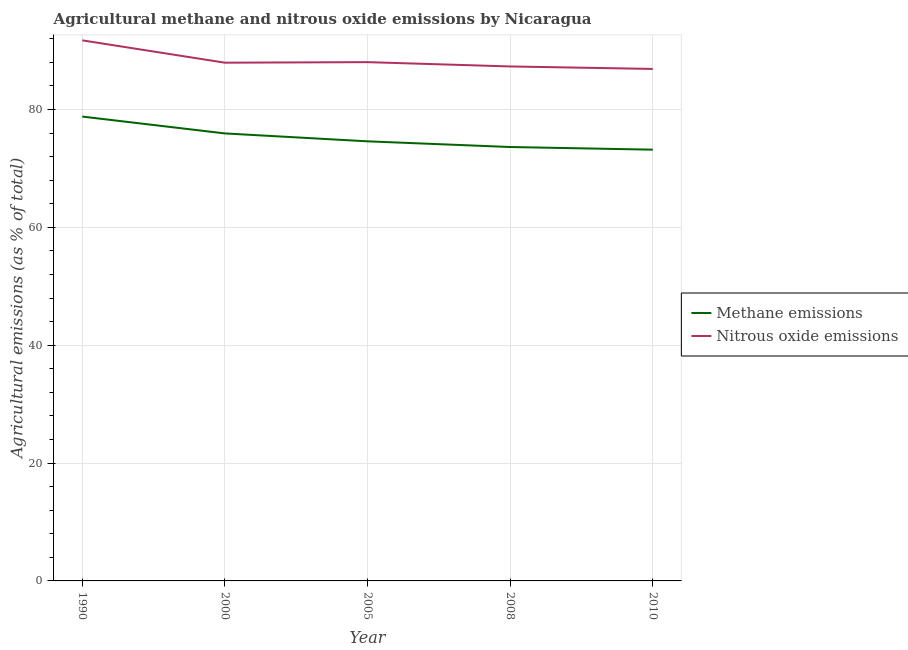What is the amount of methane emissions in 2010?
Offer a terse response. 73.19. Across all years, what is the maximum amount of methane emissions?
Your response must be concise. 78.81. Across all years, what is the minimum amount of nitrous oxide emissions?
Provide a short and direct response. 86.89. In which year was the amount of nitrous oxide emissions maximum?
Keep it short and to the point. 1990. In which year was the amount of nitrous oxide emissions minimum?
Ensure brevity in your answer.  2010. What is the total amount of methane emissions in the graph?
Make the answer very short. 376.2. What is the difference between the amount of methane emissions in 1990 and that in 2005?
Provide a succinct answer. 4.2. What is the difference between the amount of methane emissions in 2008 and the amount of nitrous oxide emissions in 1990?
Give a very brief answer. -18.1. What is the average amount of methane emissions per year?
Your answer should be compact. 75.24. In the year 2000, what is the difference between the amount of methane emissions and amount of nitrous oxide emissions?
Your response must be concise. -12.01. What is the ratio of the amount of nitrous oxide emissions in 2000 to that in 2008?
Offer a very short reply. 1.01. Is the difference between the amount of methane emissions in 2005 and 2010 greater than the difference between the amount of nitrous oxide emissions in 2005 and 2010?
Give a very brief answer. Yes. What is the difference between the highest and the second highest amount of methane emissions?
Offer a very short reply. 2.86. What is the difference between the highest and the lowest amount of nitrous oxide emissions?
Give a very brief answer. 4.85. In how many years, is the amount of nitrous oxide emissions greater than the average amount of nitrous oxide emissions taken over all years?
Give a very brief answer. 1. Is the amount of nitrous oxide emissions strictly greater than the amount of methane emissions over the years?
Keep it short and to the point. Yes. Is the amount of nitrous oxide emissions strictly less than the amount of methane emissions over the years?
Offer a very short reply. No. How many lines are there?
Offer a very short reply. 2. Does the graph contain any zero values?
Your answer should be very brief. No. How many legend labels are there?
Provide a succinct answer. 2. What is the title of the graph?
Provide a short and direct response. Agricultural methane and nitrous oxide emissions by Nicaragua. Does "UN agencies" appear as one of the legend labels in the graph?
Your answer should be compact. No. What is the label or title of the X-axis?
Give a very brief answer. Year. What is the label or title of the Y-axis?
Your answer should be very brief. Agricultural emissions (as % of total). What is the Agricultural emissions (as % of total) in Methane emissions in 1990?
Provide a succinct answer. 78.81. What is the Agricultural emissions (as % of total) in Nitrous oxide emissions in 1990?
Ensure brevity in your answer.  91.75. What is the Agricultural emissions (as % of total) in Methane emissions in 2000?
Your response must be concise. 75.95. What is the Agricultural emissions (as % of total) of Nitrous oxide emissions in 2000?
Keep it short and to the point. 87.95. What is the Agricultural emissions (as % of total) of Methane emissions in 2005?
Offer a terse response. 74.61. What is the Agricultural emissions (as % of total) of Nitrous oxide emissions in 2005?
Provide a succinct answer. 88.05. What is the Agricultural emissions (as % of total) of Methane emissions in 2008?
Offer a terse response. 73.64. What is the Agricultural emissions (as % of total) in Nitrous oxide emissions in 2008?
Keep it short and to the point. 87.32. What is the Agricultural emissions (as % of total) of Methane emissions in 2010?
Provide a short and direct response. 73.19. What is the Agricultural emissions (as % of total) in Nitrous oxide emissions in 2010?
Provide a succinct answer. 86.89. Across all years, what is the maximum Agricultural emissions (as % of total) in Methane emissions?
Keep it short and to the point. 78.81. Across all years, what is the maximum Agricultural emissions (as % of total) of Nitrous oxide emissions?
Keep it short and to the point. 91.75. Across all years, what is the minimum Agricultural emissions (as % of total) of Methane emissions?
Your answer should be very brief. 73.19. Across all years, what is the minimum Agricultural emissions (as % of total) of Nitrous oxide emissions?
Ensure brevity in your answer.  86.89. What is the total Agricultural emissions (as % of total) of Methane emissions in the graph?
Provide a short and direct response. 376.2. What is the total Agricultural emissions (as % of total) in Nitrous oxide emissions in the graph?
Offer a terse response. 441.96. What is the difference between the Agricultural emissions (as % of total) in Methane emissions in 1990 and that in 2000?
Your response must be concise. 2.86. What is the difference between the Agricultural emissions (as % of total) of Nitrous oxide emissions in 1990 and that in 2000?
Keep it short and to the point. 3.79. What is the difference between the Agricultural emissions (as % of total) in Methane emissions in 1990 and that in 2005?
Make the answer very short. 4.2. What is the difference between the Agricultural emissions (as % of total) of Nitrous oxide emissions in 1990 and that in 2005?
Keep it short and to the point. 3.7. What is the difference between the Agricultural emissions (as % of total) in Methane emissions in 1990 and that in 2008?
Provide a succinct answer. 5.17. What is the difference between the Agricultural emissions (as % of total) in Nitrous oxide emissions in 1990 and that in 2008?
Give a very brief answer. 4.43. What is the difference between the Agricultural emissions (as % of total) of Methane emissions in 1990 and that in 2010?
Provide a succinct answer. 5.62. What is the difference between the Agricultural emissions (as % of total) of Nitrous oxide emissions in 1990 and that in 2010?
Provide a short and direct response. 4.85. What is the difference between the Agricultural emissions (as % of total) in Methane emissions in 2000 and that in 2005?
Your response must be concise. 1.34. What is the difference between the Agricultural emissions (as % of total) of Nitrous oxide emissions in 2000 and that in 2005?
Offer a very short reply. -0.09. What is the difference between the Agricultural emissions (as % of total) of Methane emissions in 2000 and that in 2008?
Your answer should be very brief. 2.31. What is the difference between the Agricultural emissions (as % of total) in Nitrous oxide emissions in 2000 and that in 2008?
Your response must be concise. 0.64. What is the difference between the Agricultural emissions (as % of total) of Methane emissions in 2000 and that in 2010?
Give a very brief answer. 2.76. What is the difference between the Agricultural emissions (as % of total) of Nitrous oxide emissions in 2000 and that in 2010?
Your response must be concise. 1.06. What is the difference between the Agricultural emissions (as % of total) of Methane emissions in 2005 and that in 2008?
Keep it short and to the point. 0.96. What is the difference between the Agricultural emissions (as % of total) of Nitrous oxide emissions in 2005 and that in 2008?
Ensure brevity in your answer.  0.73. What is the difference between the Agricultural emissions (as % of total) in Methane emissions in 2005 and that in 2010?
Offer a very short reply. 1.42. What is the difference between the Agricultural emissions (as % of total) of Nitrous oxide emissions in 2005 and that in 2010?
Keep it short and to the point. 1.15. What is the difference between the Agricultural emissions (as % of total) of Methane emissions in 2008 and that in 2010?
Your response must be concise. 0.45. What is the difference between the Agricultural emissions (as % of total) of Nitrous oxide emissions in 2008 and that in 2010?
Provide a short and direct response. 0.42. What is the difference between the Agricultural emissions (as % of total) of Methane emissions in 1990 and the Agricultural emissions (as % of total) of Nitrous oxide emissions in 2000?
Provide a short and direct response. -9.14. What is the difference between the Agricultural emissions (as % of total) in Methane emissions in 1990 and the Agricultural emissions (as % of total) in Nitrous oxide emissions in 2005?
Your answer should be very brief. -9.24. What is the difference between the Agricultural emissions (as % of total) of Methane emissions in 1990 and the Agricultural emissions (as % of total) of Nitrous oxide emissions in 2008?
Your response must be concise. -8.51. What is the difference between the Agricultural emissions (as % of total) in Methane emissions in 1990 and the Agricultural emissions (as % of total) in Nitrous oxide emissions in 2010?
Your answer should be very brief. -8.08. What is the difference between the Agricultural emissions (as % of total) in Methane emissions in 2000 and the Agricultural emissions (as % of total) in Nitrous oxide emissions in 2005?
Offer a terse response. -12.1. What is the difference between the Agricultural emissions (as % of total) of Methane emissions in 2000 and the Agricultural emissions (as % of total) of Nitrous oxide emissions in 2008?
Your response must be concise. -11.37. What is the difference between the Agricultural emissions (as % of total) of Methane emissions in 2000 and the Agricultural emissions (as % of total) of Nitrous oxide emissions in 2010?
Make the answer very short. -10.94. What is the difference between the Agricultural emissions (as % of total) of Methane emissions in 2005 and the Agricultural emissions (as % of total) of Nitrous oxide emissions in 2008?
Make the answer very short. -12.71. What is the difference between the Agricultural emissions (as % of total) of Methane emissions in 2005 and the Agricultural emissions (as % of total) of Nitrous oxide emissions in 2010?
Make the answer very short. -12.29. What is the difference between the Agricultural emissions (as % of total) of Methane emissions in 2008 and the Agricultural emissions (as % of total) of Nitrous oxide emissions in 2010?
Your response must be concise. -13.25. What is the average Agricultural emissions (as % of total) in Methane emissions per year?
Keep it short and to the point. 75.24. What is the average Agricultural emissions (as % of total) in Nitrous oxide emissions per year?
Ensure brevity in your answer.  88.39. In the year 1990, what is the difference between the Agricultural emissions (as % of total) in Methane emissions and Agricultural emissions (as % of total) in Nitrous oxide emissions?
Give a very brief answer. -12.94. In the year 2000, what is the difference between the Agricultural emissions (as % of total) of Methane emissions and Agricultural emissions (as % of total) of Nitrous oxide emissions?
Give a very brief answer. -12.01. In the year 2005, what is the difference between the Agricultural emissions (as % of total) in Methane emissions and Agricultural emissions (as % of total) in Nitrous oxide emissions?
Provide a short and direct response. -13.44. In the year 2008, what is the difference between the Agricultural emissions (as % of total) in Methane emissions and Agricultural emissions (as % of total) in Nitrous oxide emissions?
Provide a succinct answer. -13.67. In the year 2010, what is the difference between the Agricultural emissions (as % of total) in Methane emissions and Agricultural emissions (as % of total) in Nitrous oxide emissions?
Make the answer very short. -13.7. What is the ratio of the Agricultural emissions (as % of total) of Methane emissions in 1990 to that in 2000?
Make the answer very short. 1.04. What is the ratio of the Agricultural emissions (as % of total) of Nitrous oxide emissions in 1990 to that in 2000?
Keep it short and to the point. 1.04. What is the ratio of the Agricultural emissions (as % of total) of Methane emissions in 1990 to that in 2005?
Provide a succinct answer. 1.06. What is the ratio of the Agricultural emissions (as % of total) in Nitrous oxide emissions in 1990 to that in 2005?
Provide a succinct answer. 1.04. What is the ratio of the Agricultural emissions (as % of total) of Methane emissions in 1990 to that in 2008?
Your response must be concise. 1.07. What is the ratio of the Agricultural emissions (as % of total) in Nitrous oxide emissions in 1990 to that in 2008?
Give a very brief answer. 1.05. What is the ratio of the Agricultural emissions (as % of total) of Methane emissions in 1990 to that in 2010?
Your answer should be compact. 1.08. What is the ratio of the Agricultural emissions (as % of total) of Nitrous oxide emissions in 1990 to that in 2010?
Provide a short and direct response. 1.06. What is the ratio of the Agricultural emissions (as % of total) of Methane emissions in 2000 to that in 2005?
Keep it short and to the point. 1.02. What is the ratio of the Agricultural emissions (as % of total) of Nitrous oxide emissions in 2000 to that in 2005?
Offer a terse response. 1. What is the ratio of the Agricultural emissions (as % of total) of Methane emissions in 2000 to that in 2008?
Provide a short and direct response. 1.03. What is the ratio of the Agricultural emissions (as % of total) in Nitrous oxide emissions in 2000 to that in 2008?
Offer a terse response. 1.01. What is the ratio of the Agricultural emissions (as % of total) in Methane emissions in 2000 to that in 2010?
Ensure brevity in your answer.  1.04. What is the ratio of the Agricultural emissions (as % of total) in Nitrous oxide emissions in 2000 to that in 2010?
Ensure brevity in your answer.  1.01. What is the ratio of the Agricultural emissions (as % of total) of Methane emissions in 2005 to that in 2008?
Give a very brief answer. 1.01. What is the ratio of the Agricultural emissions (as % of total) in Nitrous oxide emissions in 2005 to that in 2008?
Make the answer very short. 1.01. What is the ratio of the Agricultural emissions (as % of total) in Methane emissions in 2005 to that in 2010?
Your answer should be very brief. 1.02. What is the ratio of the Agricultural emissions (as % of total) of Nitrous oxide emissions in 2005 to that in 2010?
Your answer should be very brief. 1.01. What is the difference between the highest and the second highest Agricultural emissions (as % of total) in Methane emissions?
Make the answer very short. 2.86. What is the difference between the highest and the second highest Agricultural emissions (as % of total) in Nitrous oxide emissions?
Your answer should be compact. 3.7. What is the difference between the highest and the lowest Agricultural emissions (as % of total) of Methane emissions?
Your response must be concise. 5.62. What is the difference between the highest and the lowest Agricultural emissions (as % of total) in Nitrous oxide emissions?
Keep it short and to the point. 4.85. 